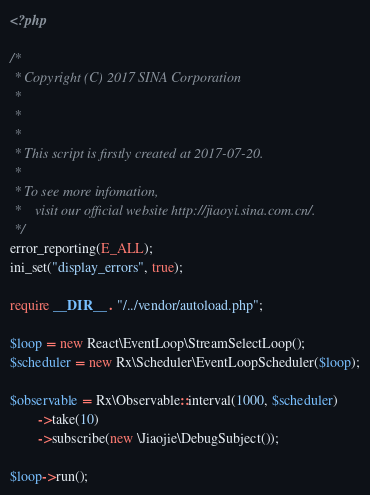Convert code to text. <code><loc_0><loc_0><loc_500><loc_500><_PHP_><?php

/*
 * Copyright (C) 2017 SINA Corporation
 *  
 *  
 * 
 * This script is firstly created at 2017-07-20.
 * 
 * To see more infomation,
 *    visit our official website http://jiaoyi.sina.com.cn/.
 */
error_reporting(E_ALL);
ini_set("display_errors", true);

require __DIR__ . "/../vendor/autoload.php";

$loop = new React\EventLoop\StreamSelectLoop();
$scheduler = new Rx\Scheduler\EventLoopScheduler($loop);

$observable = Rx\Observable::interval(1000, $scheduler)
        ->take(10)
        ->subscribe(new \Jiaojie\DebugSubject());

$loop->run();
</code> 